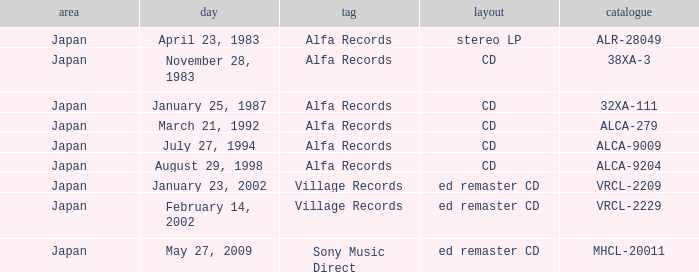Which date is in stereo lp format? April 23, 1983. 